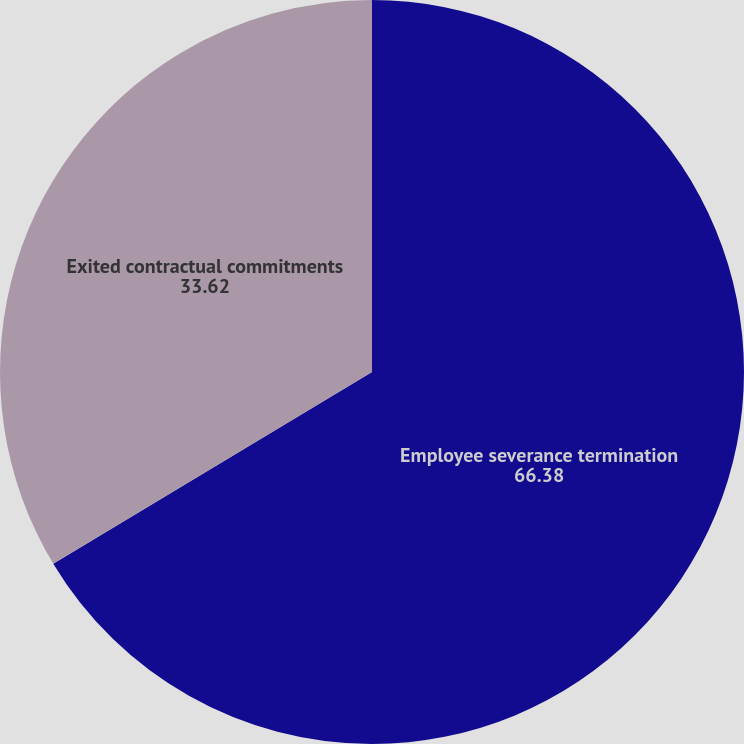Convert chart. <chart><loc_0><loc_0><loc_500><loc_500><pie_chart><fcel>Employee severance termination<fcel>Exited contractual commitments<nl><fcel>66.38%<fcel>33.62%<nl></chart> 